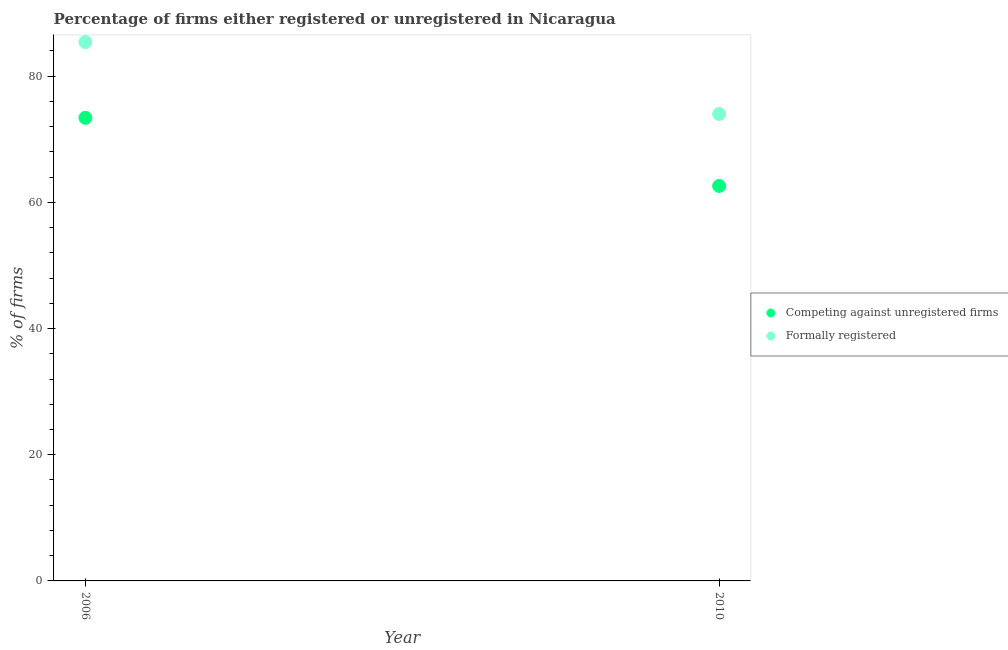How many different coloured dotlines are there?
Provide a succinct answer. 2. What is the percentage of registered firms in 2010?
Ensure brevity in your answer.  62.6. Across all years, what is the maximum percentage of formally registered firms?
Make the answer very short. 85.4. Across all years, what is the minimum percentage of formally registered firms?
Keep it short and to the point. 74. In which year was the percentage of formally registered firms maximum?
Your response must be concise. 2006. In which year was the percentage of registered firms minimum?
Provide a succinct answer. 2010. What is the total percentage of registered firms in the graph?
Ensure brevity in your answer.  136. What is the difference between the percentage of formally registered firms in 2006 and that in 2010?
Your answer should be compact. 11.4. What is the difference between the percentage of registered firms in 2010 and the percentage of formally registered firms in 2006?
Offer a terse response. -22.8. What is the average percentage of formally registered firms per year?
Keep it short and to the point. 79.7. In the year 2010, what is the difference between the percentage of registered firms and percentage of formally registered firms?
Keep it short and to the point. -11.4. In how many years, is the percentage of registered firms greater than 24 %?
Keep it short and to the point. 2. What is the ratio of the percentage of registered firms in 2006 to that in 2010?
Provide a short and direct response. 1.17. Is the percentage of formally registered firms strictly greater than the percentage of registered firms over the years?
Provide a succinct answer. Yes. How many dotlines are there?
Keep it short and to the point. 2. Does the graph contain any zero values?
Ensure brevity in your answer.  No. Where does the legend appear in the graph?
Provide a short and direct response. Center right. How many legend labels are there?
Make the answer very short. 2. How are the legend labels stacked?
Give a very brief answer. Vertical. What is the title of the graph?
Give a very brief answer. Percentage of firms either registered or unregistered in Nicaragua. What is the label or title of the X-axis?
Ensure brevity in your answer.  Year. What is the label or title of the Y-axis?
Offer a terse response. % of firms. What is the % of firms in Competing against unregistered firms in 2006?
Offer a very short reply. 73.4. What is the % of firms in Formally registered in 2006?
Keep it short and to the point. 85.4. What is the % of firms in Competing against unregistered firms in 2010?
Your answer should be compact. 62.6. Across all years, what is the maximum % of firms in Competing against unregistered firms?
Provide a short and direct response. 73.4. Across all years, what is the maximum % of firms in Formally registered?
Provide a succinct answer. 85.4. Across all years, what is the minimum % of firms in Competing against unregistered firms?
Give a very brief answer. 62.6. Across all years, what is the minimum % of firms in Formally registered?
Your answer should be very brief. 74. What is the total % of firms in Competing against unregistered firms in the graph?
Your answer should be compact. 136. What is the total % of firms in Formally registered in the graph?
Your answer should be very brief. 159.4. What is the difference between the % of firms of Competing against unregistered firms in 2006 and that in 2010?
Your answer should be very brief. 10.8. What is the difference between the % of firms of Competing against unregistered firms in 2006 and the % of firms of Formally registered in 2010?
Keep it short and to the point. -0.6. What is the average % of firms of Competing against unregistered firms per year?
Ensure brevity in your answer.  68. What is the average % of firms in Formally registered per year?
Make the answer very short. 79.7. In the year 2006, what is the difference between the % of firms of Competing against unregistered firms and % of firms of Formally registered?
Offer a very short reply. -12. In the year 2010, what is the difference between the % of firms in Competing against unregistered firms and % of firms in Formally registered?
Your answer should be very brief. -11.4. What is the ratio of the % of firms in Competing against unregistered firms in 2006 to that in 2010?
Your response must be concise. 1.17. What is the ratio of the % of firms in Formally registered in 2006 to that in 2010?
Offer a very short reply. 1.15. 